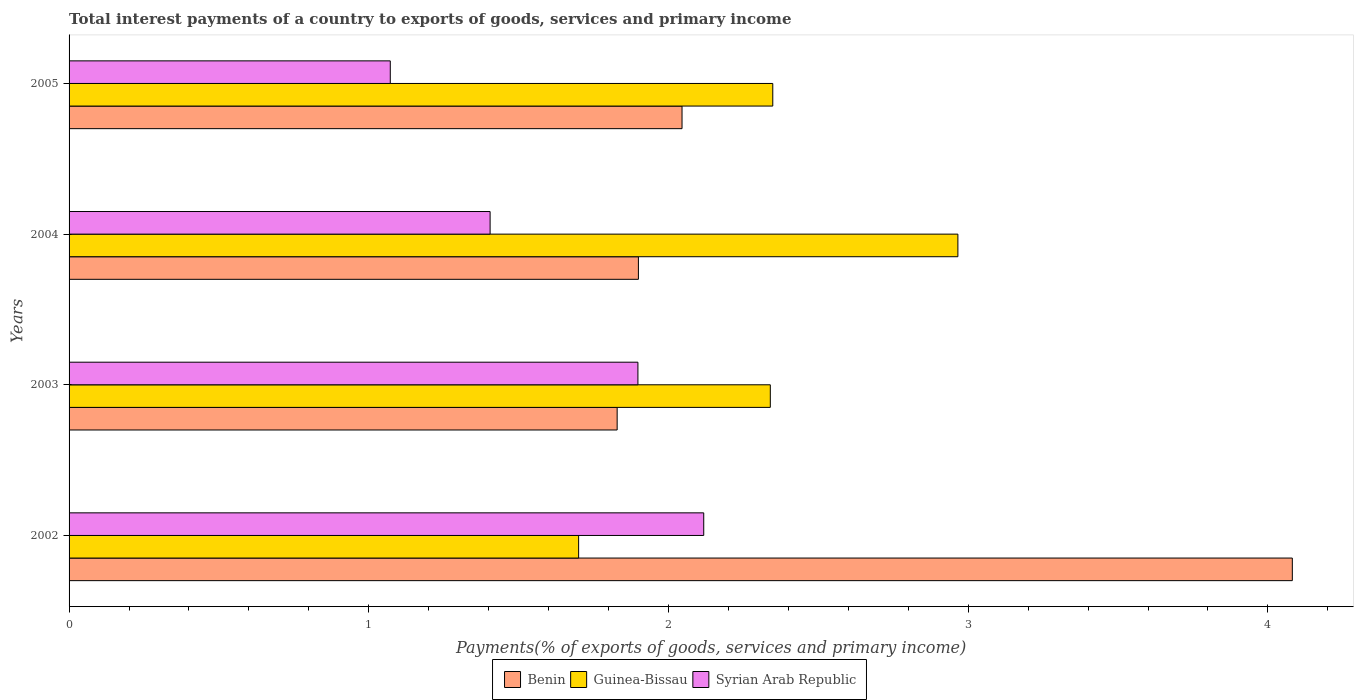How many different coloured bars are there?
Make the answer very short. 3. How many groups of bars are there?
Offer a terse response. 4. Are the number of bars on each tick of the Y-axis equal?
Provide a succinct answer. Yes. How many bars are there on the 3rd tick from the top?
Offer a terse response. 3. How many bars are there on the 1st tick from the bottom?
Provide a succinct answer. 3. In how many cases, is the number of bars for a given year not equal to the number of legend labels?
Your answer should be very brief. 0. What is the total interest payments in Guinea-Bissau in 2002?
Your answer should be very brief. 1.7. Across all years, what is the maximum total interest payments in Benin?
Give a very brief answer. 4.08. Across all years, what is the minimum total interest payments in Syrian Arab Republic?
Your answer should be very brief. 1.07. In which year was the total interest payments in Syrian Arab Republic minimum?
Offer a very short reply. 2005. What is the total total interest payments in Benin in the graph?
Give a very brief answer. 9.86. What is the difference between the total interest payments in Guinea-Bissau in 2003 and that in 2004?
Your answer should be compact. -0.63. What is the difference between the total interest payments in Guinea-Bissau in 2004 and the total interest payments in Syrian Arab Republic in 2003?
Your answer should be very brief. 1.07. What is the average total interest payments in Guinea-Bissau per year?
Provide a short and direct response. 2.34. In the year 2005, what is the difference between the total interest payments in Syrian Arab Republic and total interest payments in Benin?
Offer a very short reply. -0.97. What is the ratio of the total interest payments in Syrian Arab Republic in 2002 to that in 2003?
Offer a very short reply. 1.12. Is the difference between the total interest payments in Syrian Arab Republic in 2003 and 2004 greater than the difference between the total interest payments in Benin in 2003 and 2004?
Your answer should be compact. Yes. What is the difference between the highest and the second highest total interest payments in Benin?
Make the answer very short. 2.04. What is the difference between the highest and the lowest total interest payments in Syrian Arab Republic?
Give a very brief answer. 1.05. In how many years, is the total interest payments in Guinea-Bissau greater than the average total interest payments in Guinea-Bissau taken over all years?
Your answer should be very brief. 3. Is the sum of the total interest payments in Guinea-Bissau in 2002 and 2004 greater than the maximum total interest payments in Benin across all years?
Provide a short and direct response. Yes. What does the 3rd bar from the top in 2003 represents?
Ensure brevity in your answer.  Benin. What does the 2nd bar from the bottom in 2004 represents?
Ensure brevity in your answer.  Guinea-Bissau. Is it the case that in every year, the sum of the total interest payments in Guinea-Bissau and total interest payments in Syrian Arab Republic is greater than the total interest payments in Benin?
Make the answer very short. No. How many years are there in the graph?
Keep it short and to the point. 4. What is the difference between two consecutive major ticks on the X-axis?
Give a very brief answer. 1. Does the graph contain any zero values?
Your answer should be very brief. No. Where does the legend appear in the graph?
Provide a succinct answer. Bottom center. What is the title of the graph?
Make the answer very short. Total interest payments of a country to exports of goods, services and primary income. Does "Tanzania" appear as one of the legend labels in the graph?
Make the answer very short. No. What is the label or title of the X-axis?
Your answer should be compact. Payments(% of exports of goods, services and primary income). What is the label or title of the Y-axis?
Provide a succinct answer. Years. What is the Payments(% of exports of goods, services and primary income) of Benin in 2002?
Offer a very short reply. 4.08. What is the Payments(% of exports of goods, services and primary income) of Guinea-Bissau in 2002?
Ensure brevity in your answer.  1.7. What is the Payments(% of exports of goods, services and primary income) of Syrian Arab Republic in 2002?
Offer a very short reply. 2.12. What is the Payments(% of exports of goods, services and primary income) in Benin in 2003?
Ensure brevity in your answer.  1.83. What is the Payments(% of exports of goods, services and primary income) in Guinea-Bissau in 2003?
Provide a succinct answer. 2.34. What is the Payments(% of exports of goods, services and primary income) in Syrian Arab Republic in 2003?
Keep it short and to the point. 1.9. What is the Payments(% of exports of goods, services and primary income) in Benin in 2004?
Make the answer very short. 1.9. What is the Payments(% of exports of goods, services and primary income) of Guinea-Bissau in 2004?
Make the answer very short. 2.97. What is the Payments(% of exports of goods, services and primary income) in Syrian Arab Republic in 2004?
Keep it short and to the point. 1.4. What is the Payments(% of exports of goods, services and primary income) in Benin in 2005?
Your answer should be compact. 2.05. What is the Payments(% of exports of goods, services and primary income) of Guinea-Bissau in 2005?
Provide a short and direct response. 2.35. What is the Payments(% of exports of goods, services and primary income) in Syrian Arab Republic in 2005?
Provide a short and direct response. 1.07. Across all years, what is the maximum Payments(% of exports of goods, services and primary income) in Benin?
Your response must be concise. 4.08. Across all years, what is the maximum Payments(% of exports of goods, services and primary income) of Guinea-Bissau?
Provide a short and direct response. 2.97. Across all years, what is the maximum Payments(% of exports of goods, services and primary income) in Syrian Arab Republic?
Provide a succinct answer. 2.12. Across all years, what is the minimum Payments(% of exports of goods, services and primary income) in Benin?
Offer a terse response. 1.83. Across all years, what is the minimum Payments(% of exports of goods, services and primary income) of Guinea-Bissau?
Your response must be concise. 1.7. Across all years, what is the minimum Payments(% of exports of goods, services and primary income) of Syrian Arab Republic?
Offer a terse response. 1.07. What is the total Payments(% of exports of goods, services and primary income) of Benin in the graph?
Your response must be concise. 9.86. What is the total Payments(% of exports of goods, services and primary income) of Guinea-Bissau in the graph?
Provide a succinct answer. 9.35. What is the total Payments(% of exports of goods, services and primary income) in Syrian Arab Republic in the graph?
Offer a very short reply. 6.49. What is the difference between the Payments(% of exports of goods, services and primary income) in Benin in 2002 and that in 2003?
Provide a succinct answer. 2.25. What is the difference between the Payments(% of exports of goods, services and primary income) in Guinea-Bissau in 2002 and that in 2003?
Offer a very short reply. -0.64. What is the difference between the Payments(% of exports of goods, services and primary income) in Syrian Arab Republic in 2002 and that in 2003?
Give a very brief answer. 0.22. What is the difference between the Payments(% of exports of goods, services and primary income) of Benin in 2002 and that in 2004?
Give a very brief answer. 2.18. What is the difference between the Payments(% of exports of goods, services and primary income) of Guinea-Bissau in 2002 and that in 2004?
Your response must be concise. -1.27. What is the difference between the Payments(% of exports of goods, services and primary income) in Syrian Arab Republic in 2002 and that in 2004?
Provide a short and direct response. 0.71. What is the difference between the Payments(% of exports of goods, services and primary income) in Benin in 2002 and that in 2005?
Ensure brevity in your answer.  2.04. What is the difference between the Payments(% of exports of goods, services and primary income) of Guinea-Bissau in 2002 and that in 2005?
Ensure brevity in your answer.  -0.65. What is the difference between the Payments(% of exports of goods, services and primary income) in Syrian Arab Republic in 2002 and that in 2005?
Make the answer very short. 1.05. What is the difference between the Payments(% of exports of goods, services and primary income) of Benin in 2003 and that in 2004?
Offer a very short reply. -0.07. What is the difference between the Payments(% of exports of goods, services and primary income) of Guinea-Bissau in 2003 and that in 2004?
Keep it short and to the point. -0.63. What is the difference between the Payments(% of exports of goods, services and primary income) of Syrian Arab Republic in 2003 and that in 2004?
Your response must be concise. 0.49. What is the difference between the Payments(% of exports of goods, services and primary income) in Benin in 2003 and that in 2005?
Provide a short and direct response. -0.22. What is the difference between the Payments(% of exports of goods, services and primary income) in Guinea-Bissau in 2003 and that in 2005?
Your answer should be very brief. -0.01. What is the difference between the Payments(% of exports of goods, services and primary income) of Syrian Arab Republic in 2003 and that in 2005?
Your answer should be very brief. 0.83. What is the difference between the Payments(% of exports of goods, services and primary income) of Benin in 2004 and that in 2005?
Your response must be concise. -0.15. What is the difference between the Payments(% of exports of goods, services and primary income) in Guinea-Bissau in 2004 and that in 2005?
Make the answer very short. 0.62. What is the difference between the Payments(% of exports of goods, services and primary income) in Syrian Arab Republic in 2004 and that in 2005?
Provide a short and direct response. 0.33. What is the difference between the Payments(% of exports of goods, services and primary income) of Benin in 2002 and the Payments(% of exports of goods, services and primary income) of Guinea-Bissau in 2003?
Offer a terse response. 1.74. What is the difference between the Payments(% of exports of goods, services and primary income) of Benin in 2002 and the Payments(% of exports of goods, services and primary income) of Syrian Arab Republic in 2003?
Provide a short and direct response. 2.18. What is the difference between the Payments(% of exports of goods, services and primary income) in Guinea-Bissau in 2002 and the Payments(% of exports of goods, services and primary income) in Syrian Arab Republic in 2003?
Offer a terse response. -0.2. What is the difference between the Payments(% of exports of goods, services and primary income) of Benin in 2002 and the Payments(% of exports of goods, services and primary income) of Guinea-Bissau in 2004?
Give a very brief answer. 1.12. What is the difference between the Payments(% of exports of goods, services and primary income) of Benin in 2002 and the Payments(% of exports of goods, services and primary income) of Syrian Arab Republic in 2004?
Offer a terse response. 2.68. What is the difference between the Payments(% of exports of goods, services and primary income) in Guinea-Bissau in 2002 and the Payments(% of exports of goods, services and primary income) in Syrian Arab Republic in 2004?
Offer a terse response. 0.3. What is the difference between the Payments(% of exports of goods, services and primary income) of Benin in 2002 and the Payments(% of exports of goods, services and primary income) of Guinea-Bissau in 2005?
Keep it short and to the point. 1.73. What is the difference between the Payments(% of exports of goods, services and primary income) in Benin in 2002 and the Payments(% of exports of goods, services and primary income) in Syrian Arab Republic in 2005?
Ensure brevity in your answer.  3.01. What is the difference between the Payments(% of exports of goods, services and primary income) of Guinea-Bissau in 2002 and the Payments(% of exports of goods, services and primary income) of Syrian Arab Republic in 2005?
Keep it short and to the point. 0.63. What is the difference between the Payments(% of exports of goods, services and primary income) of Benin in 2003 and the Payments(% of exports of goods, services and primary income) of Guinea-Bissau in 2004?
Your answer should be very brief. -1.14. What is the difference between the Payments(% of exports of goods, services and primary income) of Benin in 2003 and the Payments(% of exports of goods, services and primary income) of Syrian Arab Republic in 2004?
Your answer should be compact. 0.42. What is the difference between the Payments(% of exports of goods, services and primary income) of Guinea-Bissau in 2003 and the Payments(% of exports of goods, services and primary income) of Syrian Arab Republic in 2004?
Offer a terse response. 0.94. What is the difference between the Payments(% of exports of goods, services and primary income) in Benin in 2003 and the Payments(% of exports of goods, services and primary income) in Guinea-Bissau in 2005?
Your answer should be compact. -0.52. What is the difference between the Payments(% of exports of goods, services and primary income) in Benin in 2003 and the Payments(% of exports of goods, services and primary income) in Syrian Arab Republic in 2005?
Provide a succinct answer. 0.76. What is the difference between the Payments(% of exports of goods, services and primary income) of Guinea-Bissau in 2003 and the Payments(% of exports of goods, services and primary income) of Syrian Arab Republic in 2005?
Ensure brevity in your answer.  1.27. What is the difference between the Payments(% of exports of goods, services and primary income) in Benin in 2004 and the Payments(% of exports of goods, services and primary income) in Guinea-Bissau in 2005?
Ensure brevity in your answer.  -0.45. What is the difference between the Payments(% of exports of goods, services and primary income) in Benin in 2004 and the Payments(% of exports of goods, services and primary income) in Syrian Arab Republic in 2005?
Offer a terse response. 0.83. What is the difference between the Payments(% of exports of goods, services and primary income) of Guinea-Bissau in 2004 and the Payments(% of exports of goods, services and primary income) of Syrian Arab Republic in 2005?
Offer a very short reply. 1.89. What is the average Payments(% of exports of goods, services and primary income) in Benin per year?
Keep it short and to the point. 2.46. What is the average Payments(% of exports of goods, services and primary income) in Guinea-Bissau per year?
Your response must be concise. 2.34. What is the average Payments(% of exports of goods, services and primary income) of Syrian Arab Republic per year?
Offer a terse response. 1.62. In the year 2002, what is the difference between the Payments(% of exports of goods, services and primary income) of Benin and Payments(% of exports of goods, services and primary income) of Guinea-Bissau?
Provide a succinct answer. 2.38. In the year 2002, what is the difference between the Payments(% of exports of goods, services and primary income) of Benin and Payments(% of exports of goods, services and primary income) of Syrian Arab Republic?
Your response must be concise. 1.96. In the year 2002, what is the difference between the Payments(% of exports of goods, services and primary income) of Guinea-Bissau and Payments(% of exports of goods, services and primary income) of Syrian Arab Republic?
Keep it short and to the point. -0.42. In the year 2003, what is the difference between the Payments(% of exports of goods, services and primary income) in Benin and Payments(% of exports of goods, services and primary income) in Guinea-Bissau?
Your answer should be very brief. -0.51. In the year 2003, what is the difference between the Payments(% of exports of goods, services and primary income) in Benin and Payments(% of exports of goods, services and primary income) in Syrian Arab Republic?
Give a very brief answer. -0.07. In the year 2003, what is the difference between the Payments(% of exports of goods, services and primary income) of Guinea-Bissau and Payments(% of exports of goods, services and primary income) of Syrian Arab Republic?
Provide a short and direct response. 0.44. In the year 2004, what is the difference between the Payments(% of exports of goods, services and primary income) of Benin and Payments(% of exports of goods, services and primary income) of Guinea-Bissau?
Provide a succinct answer. -1.07. In the year 2004, what is the difference between the Payments(% of exports of goods, services and primary income) of Benin and Payments(% of exports of goods, services and primary income) of Syrian Arab Republic?
Make the answer very short. 0.49. In the year 2004, what is the difference between the Payments(% of exports of goods, services and primary income) in Guinea-Bissau and Payments(% of exports of goods, services and primary income) in Syrian Arab Republic?
Your answer should be very brief. 1.56. In the year 2005, what is the difference between the Payments(% of exports of goods, services and primary income) in Benin and Payments(% of exports of goods, services and primary income) in Guinea-Bissau?
Make the answer very short. -0.3. In the year 2005, what is the difference between the Payments(% of exports of goods, services and primary income) of Benin and Payments(% of exports of goods, services and primary income) of Syrian Arab Republic?
Offer a terse response. 0.97. In the year 2005, what is the difference between the Payments(% of exports of goods, services and primary income) in Guinea-Bissau and Payments(% of exports of goods, services and primary income) in Syrian Arab Republic?
Make the answer very short. 1.28. What is the ratio of the Payments(% of exports of goods, services and primary income) in Benin in 2002 to that in 2003?
Give a very brief answer. 2.23. What is the ratio of the Payments(% of exports of goods, services and primary income) of Guinea-Bissau in 2002 to that in 2003?
Your response must be concise. 0.73. What is the ratio of the Payments(% of exports of goods, services and primary income) in Syrian Arab Republic in 2002 to that in 2003?
Make the answer very short. 1.12. What is the ratio of the Payments(% of exports of goods, services and primary income) of Benin in 2002 to that in 2004?
Keep it short and to the point. 2.15. What is the ratio of the Payments(% of exports of goods, services and primary income) of Guinea-Bissau in 2002 to that in 2004?
Offer a terse response. 0.57. What is the ratio of the Payments(% of exports of goods, services and primary income) of Syrian Arab Republic in 2002 to that in 2004?
Ensure brevity in your answer.  1.51. What is the ratio of the Payments(% of exports of goods, services and primary income) of Benin in 2002 to that in 2005?
Provide a succinct answer. 2. What is the ratio of the Payments(% of exports of goods, services and primary income) in Guinea-Bissau in 2002 to that in 2005?
Keep it short and to the point. 0.72. What is the ratio of the Payments(% of exports of goods, services and primary income) in Syrian Arab Republic in 2002 to that in 2005?
Your response must be concise. 1.98. What is the ratio of the Payments(% of exports of goods, services and primary income) of Benin in 2003 to that in 2004?
Your answer should be compact. 0.96. What is the ratio of the Payments(% of exports of goods, services and primary income) in Guinea-Bissau in 2003 to that in 2004?
Make the answer very short. 0.79. What is the ratio of the Payments(% of exports of goods, services and primary income) of Syrian Arab Republic in 2003 to that in 2004?
Ensure brevity in your answer.  1.35. What is the ratio of the Payments(% of exports of goods, services and primary income) of Benin in 2003 to that in 2005?
Provide a short and direct response. 0.89. What is the ratio of the Payments(% of exports of goods, services and primary income) in Syrian Arab Republic in 2003 to that in 2005?
Provide a succinct answer. 1.77. What is the ratio of the Payments(% of exports of goods, services and primary income) in Benin in 2004 to that in 2005?
Offer a terse response. 0.93. What is the ratio of the Payments(% of exports of goods, services and primary income) of Guinea-Bissau in 2004 to that in 2005?
Keep it short and to the point. 1.26. What is the ratio of the Payments(% of exports of goods, services and primary income) of Syrian Arab Republic in 2004 to that in 2005?
Provide a succinct answer. 1.31. What is the difference between the highest and the second highest Payments(% of exports of goods, services and primary income) of Benin?
Give a very brief answer. 2.04. What is the difference between the highest and the second highest Payments(% of exports of goods, services and primary income) in Guinea-Bissau?
Keep it short and to the point. 0.62. What is the difference between the highest and the second highest Payments(% of exports of goods, services and primary income) of Syrian Arab Republic?
Offer a terse response. 0.22. What is the difference between the highest and the lowest Payments(% of exports of goods, services and primary income) in Benin?
Offer a terse response. 2.25. What is the difference between the highest and the lowest Payments(% of exports of goods, services and primary income) in Guinea-Bissau?
Your answer should be very brief. 1.27. What is the difference between the highest and the lowest Payments(% of exports of goods, services and primary income) in Syrian Arab Republic?
Your response must be concise. 1.05. 